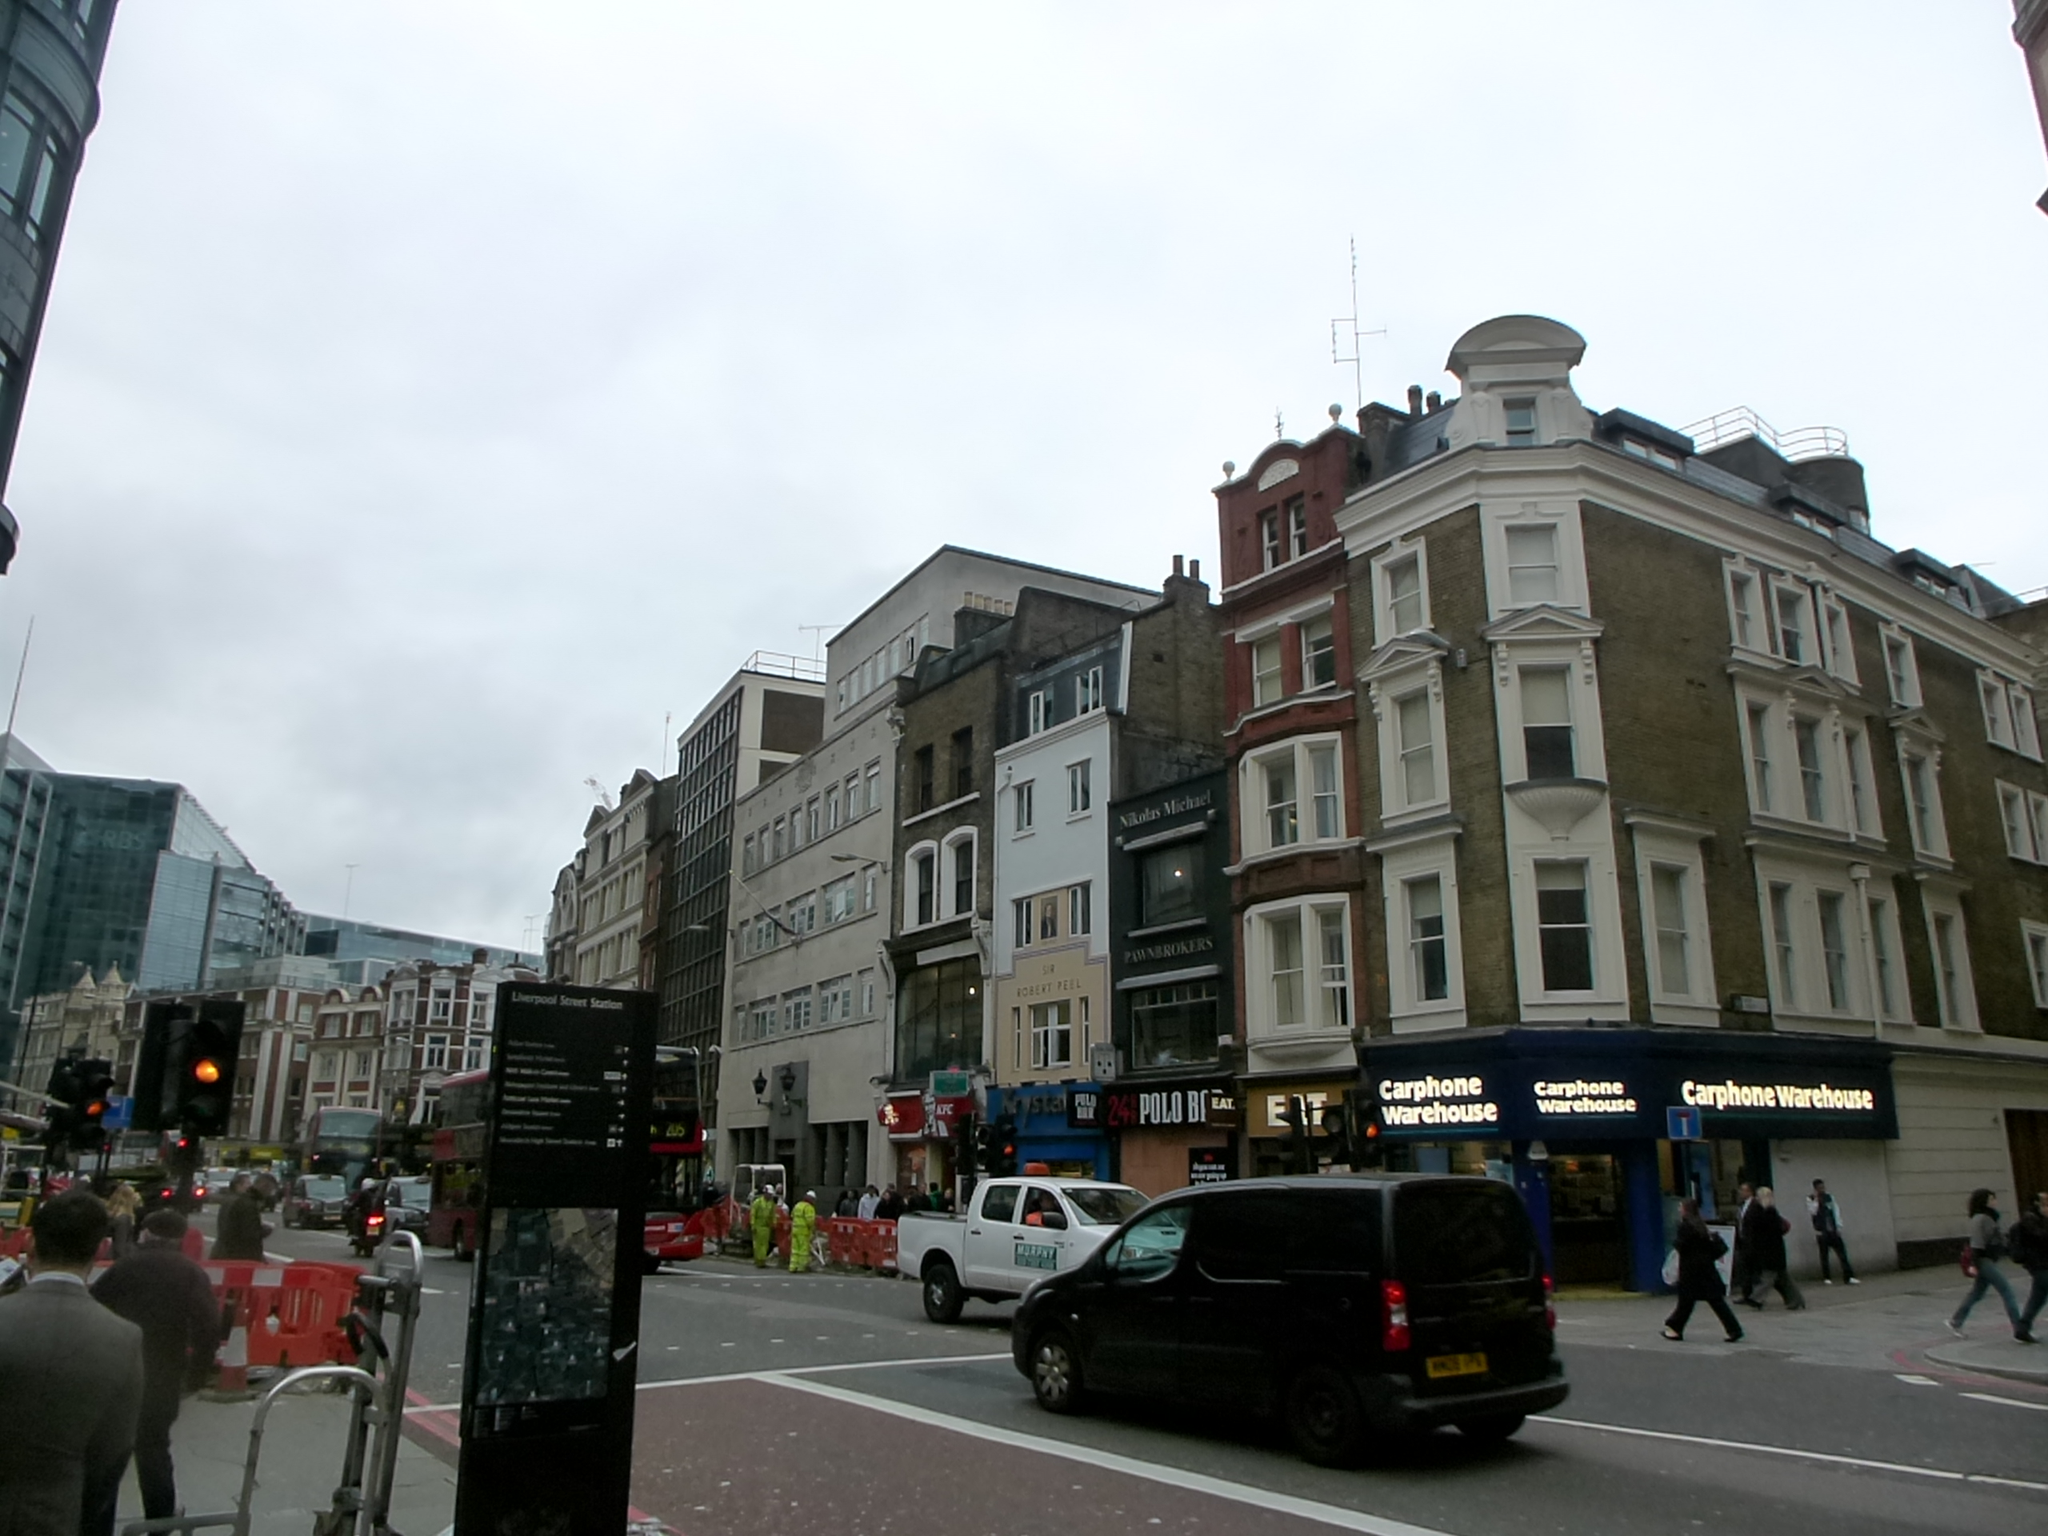In one or two sentences, can you explain what this image depicts? In this image there are many buildings and some vehicles on the road. There are also people present in this image. Image also consists of traffic light signals, name boards, red color fencing wall and sign board. At the top there is sky. 